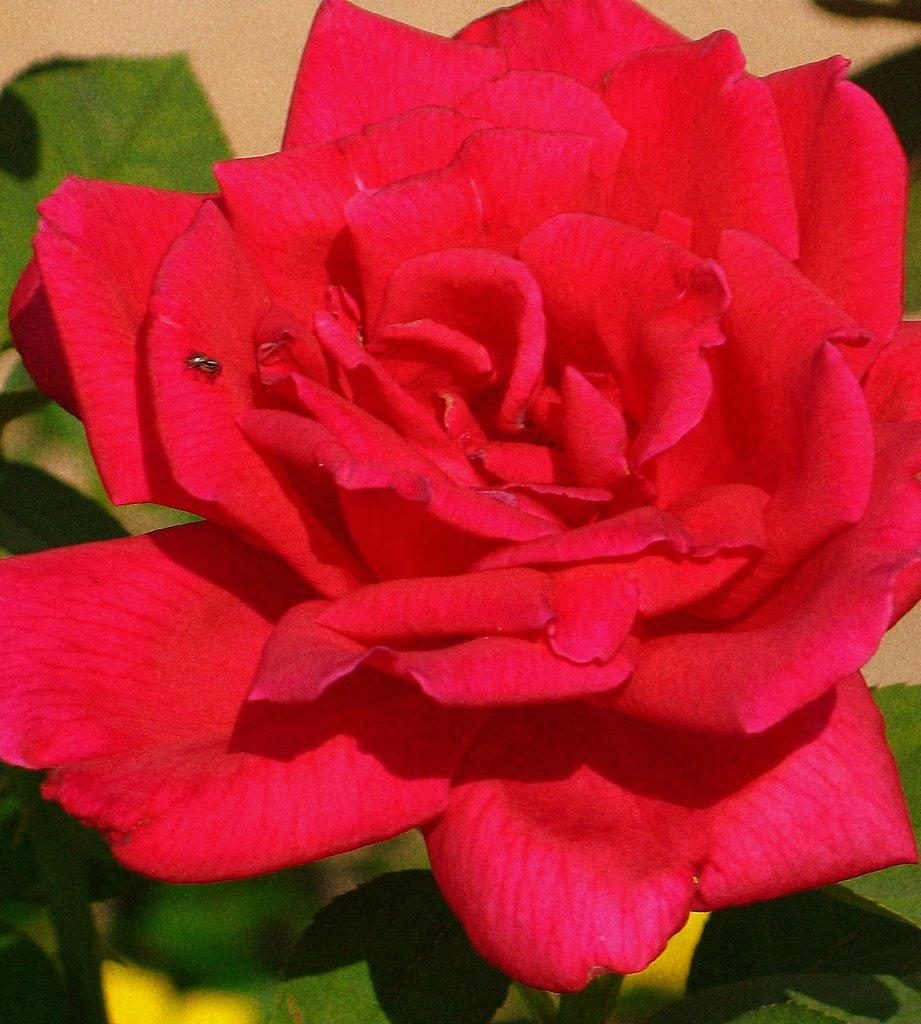What type of plant can be seen in the image? There is a flower in the image. What else is visible in the image besides the flower? There are leaves in the image. What is the credit score of the flower in the image? There is no credit score associated with the flower in the image, as credit scores are not applicable to plants. 